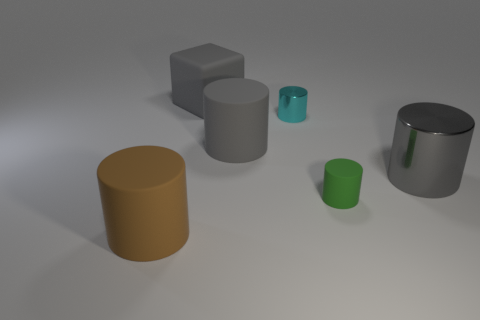Subtract all cyan cylinders. How many cylinders are left? 4 Subtract all brown cylinders. How many cylinders are left? 4 Subtract all blue cylinders. Subtract all gray spheres. How many cylinders are left? 5 Add 2 large brown matte objects. How many objects exist? 8 Subtract all cubes. How many objects are left? 5 Add 1 big red matte cubes. How many big red matte cubes exist? 1 Subtract 0 purple cylinders. How many objects are left? 6 Subtract all tiny cyan cylinders. Subtract all tiny cyan shiny cylinders. How many objects are left? 4 Add 4 gray objects. How many gray objects are left? 7 